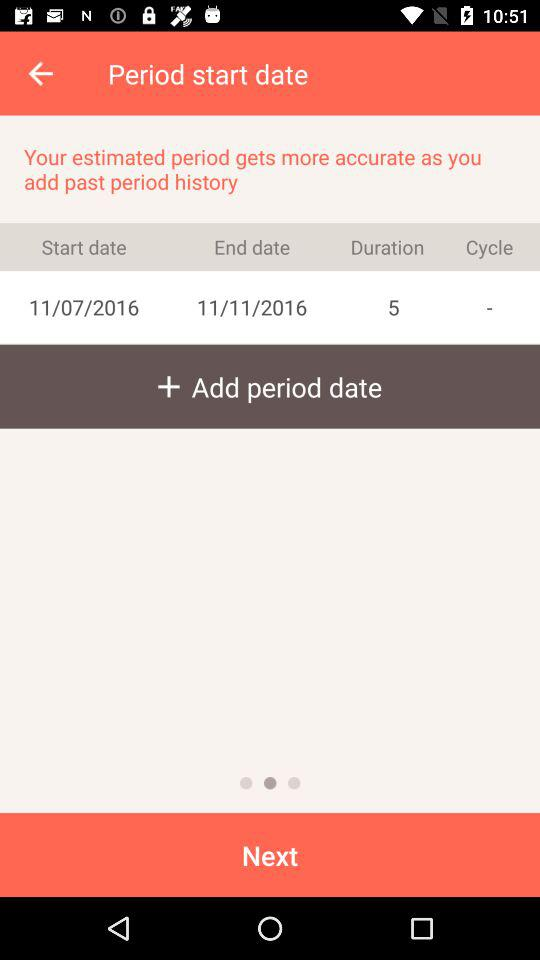What is the end date? The end date is November 11, 2016. 